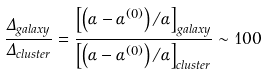<formula> <loc_0><loc_0><loc_500><loc_500>\frac { \Delta _ { g a l a x y } } { \Delta _ { c l u s t e r } } = \frac { \left [ \left ( \alpha - \alpha ^ { ( 0 ) } \right ) / \alpha \right ] _ { g a l a x y } } { \left [ \left ( \alpha - \alpha ^ { ( 0 ) } \right ) / \alpha \right ] _ { c l u s t e r } } \sim 1 0 0</formula> 